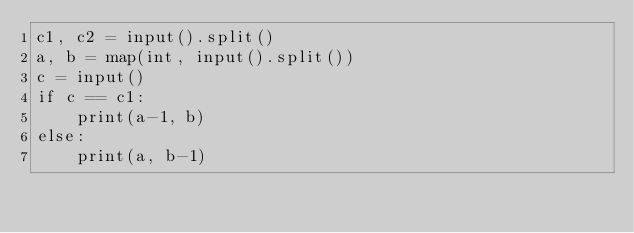<code> <loc_0><loc_0><loc_500><loc_500><_Python_>c1, c2 = input().split()
a, b = map(int, input().split())
c = input()
if c == c1:
    print(a-1, b)
else:
    print(a, b-1)
</code> 